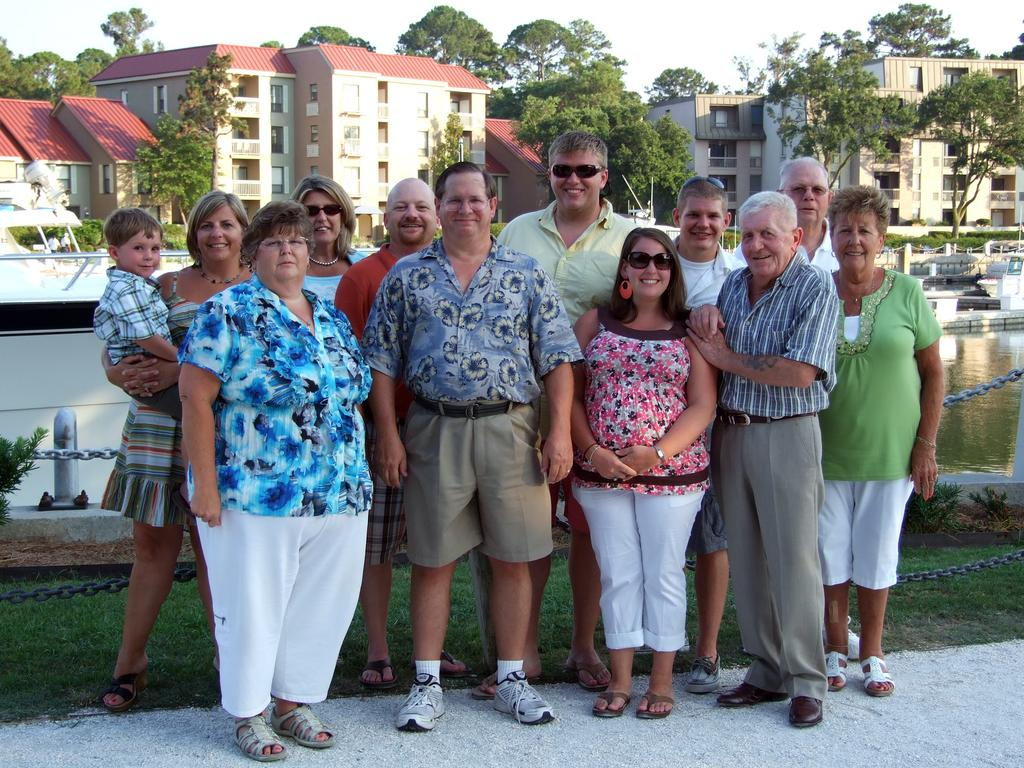How many people are in the image? There is a group of people in the image, but the exact number is not specified. What are the people doing in the image? The people are standing and smiling in the image. What can be seen behind the people? There are trees and buildings behind the people in the image. What objects are present in the image that are typically used for restraining or securing? Iron chains are present in the image. What type of vehicle is visible in the image? There is a boat in the image. What natural element is visible in the image? Water is visible in the image. What is visible in the background of the image? The sky is visible in the background of the image. What type of question is being asked by the person wearing the crown in the image? There is no person wearing a crown in the image, and therefore no such question can be asked. 